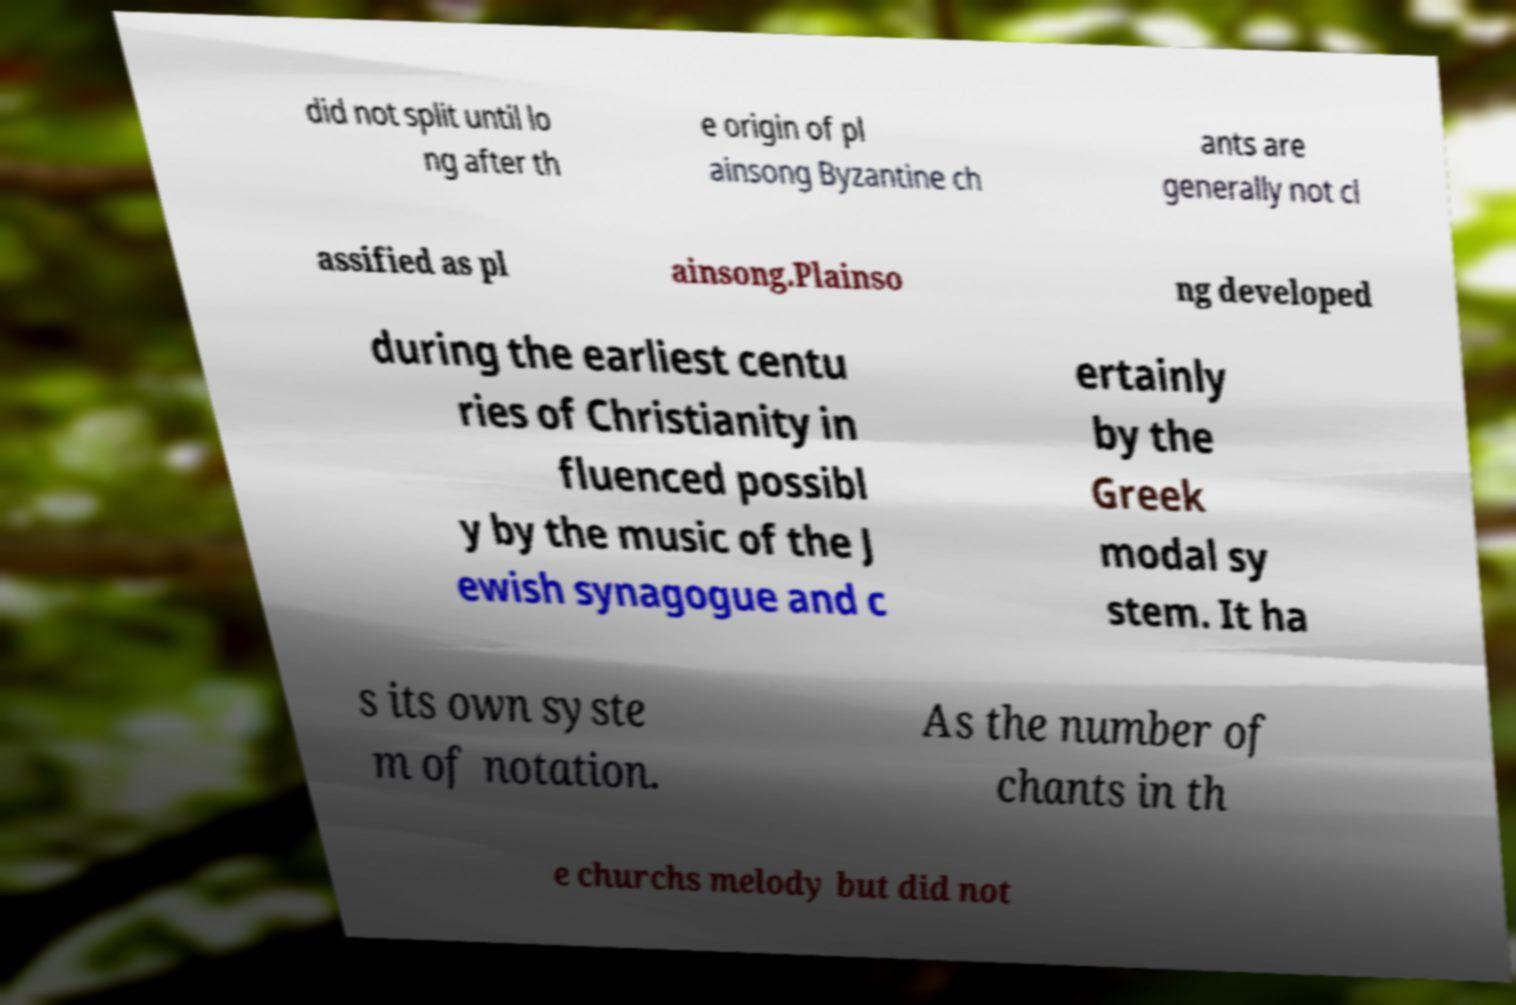There's text embedded in this image that I need extracted. Can you transcribe it verbatim? did not split until lo ng after th e origin of pl ainsong Byzantine ch ants are generally not cl assified as pl ainsong.Plainso ng developed during the earliest centu ries of Christianity in fluenced possibl y by the music of the J ewish synagogue and c ertainly by the Greek modal sy stem. It ha s its own syste m of notation. As the number of chants in th e churchs melody but did not 